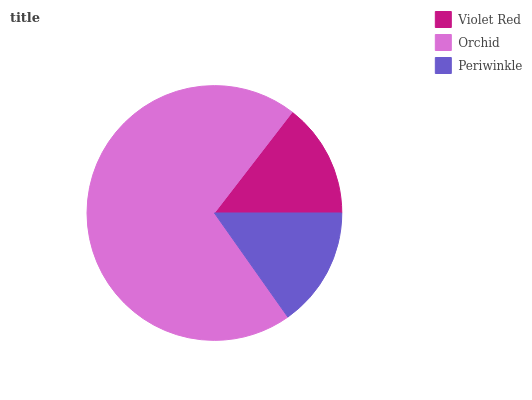Is Violet Red the minimum?
Answer yes or no. Yes. Is Orchid the maximum?
Answer yes or no. Yes. Is Periwinkle the minimum?
Answer yes or no. No. Is Periwinkle the maximum?
Answer yes or no. No. Is Orchid greater than Periwinkle?
Answer yes or no. Yes. Is Periwinkle less than Orchid?
Answer yes or no. Yes. Is Periwinkle greater than Orchid?
Answer yes or no. No. Is Orchid less than Periwinkle?
Answer yes or no. No. Is Periwinkle the high median?
Answer yes or no. Yes. Is Periwinkle the low median?
Answer yes or no. Yes. Is Violet Red the high median?
Answer yes or no. No. Is Orchid the low median?
Answer yes or no. No. 